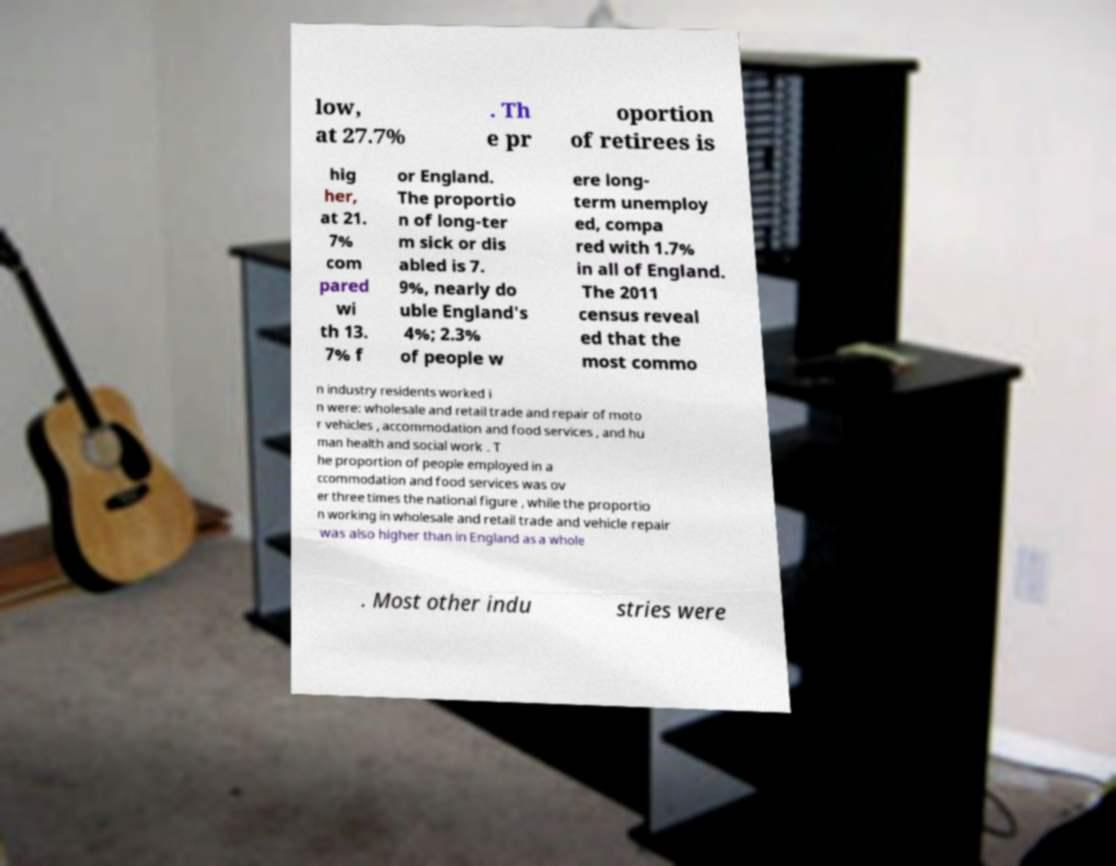What messages or text are displayed in this image? I need them in a readable, typed format. low, at 27.7% . Th e pr oportion of retirees is hig her, at 21. 7% com pared wi th 13. 7% f or England. The proportio n of long-ter m sick or dis abled is 7. 9%, nearly do uble England's 4%; 2.3% of people w ere long- term unemploy ed, compa red with 1.7% in all of England. The 2011 census reveal ed that the most commo n industry residents worked i n were: wholesale and retail trade and repair of moto r vehicles , accommodation and food services , and hu man health and social work . T he proportion of people employed in a ccommodation and food services was ov er three times the national figure , while the proportio n working in wholesale and retail trade and vehicle repair was also higher than in England as a whole . Most other indu stries were 